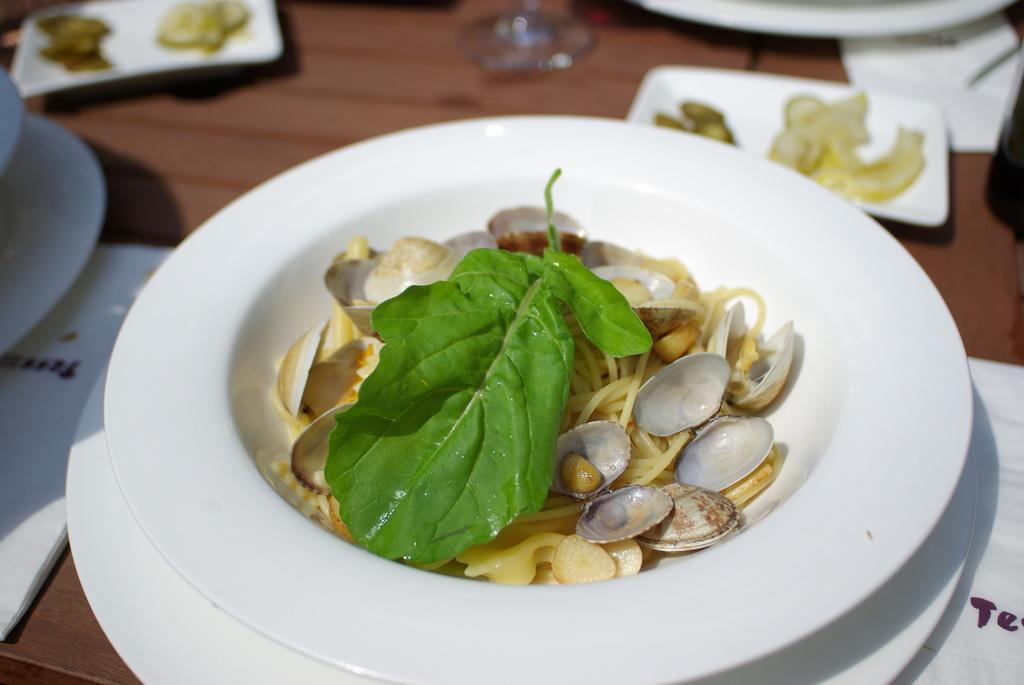What type of surface is visible in the image? There is a wooden surface in the image. What can be seen on top of the wooden surface? There are tissues and plates with food items on the wooden surface. What specific food items are on the plates? The food items include a leaf, shells, and noodles. How does the ship navigate through the food items in the image? There is no ship present in the image; it only features a wooden surface, tissues, and plates with food items. 